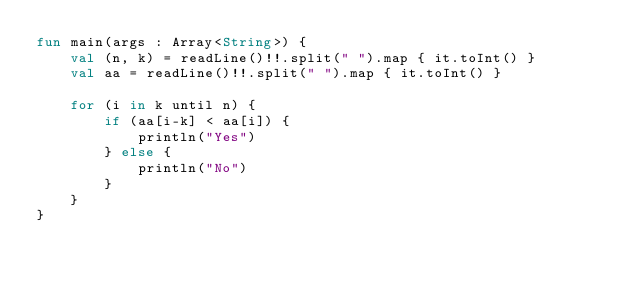Convert code to text. <code><loc_0><loc_0><loc_500><loc_500><_Kotlin_>fun main(args : Array<String>) {
    val (n, k) = readLine()!!.split(" ").map { it.toInt() }
    val aa = readLine()!!.split(" ").map { it.toInt() }

    for (i in k until n) {
        if (aa[i-k] < aa[i]) {
            println("Yes")
        } else {
            println("No")
        }
    }
}</code> 